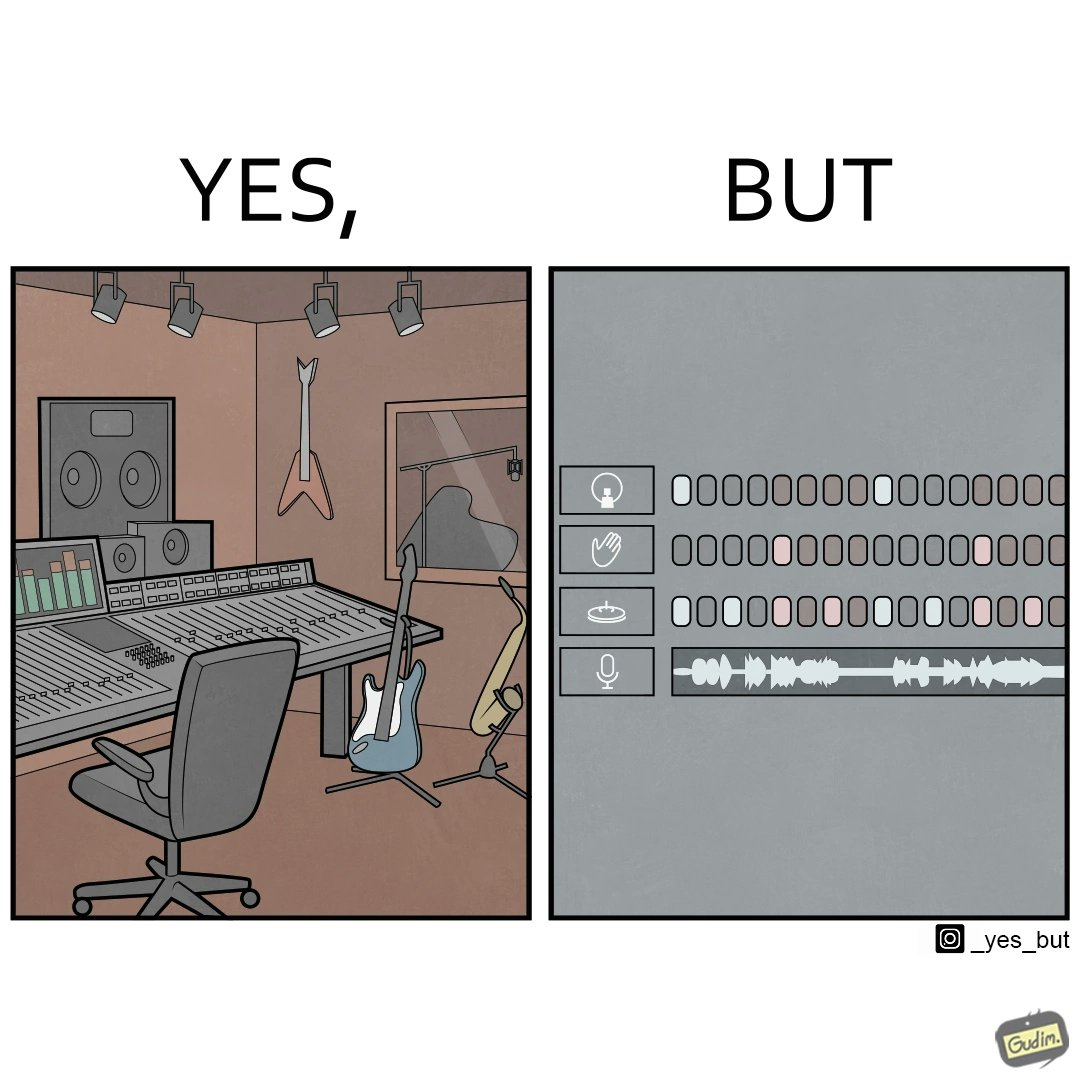Is this a satirical image? Yes, this image is satirical. 